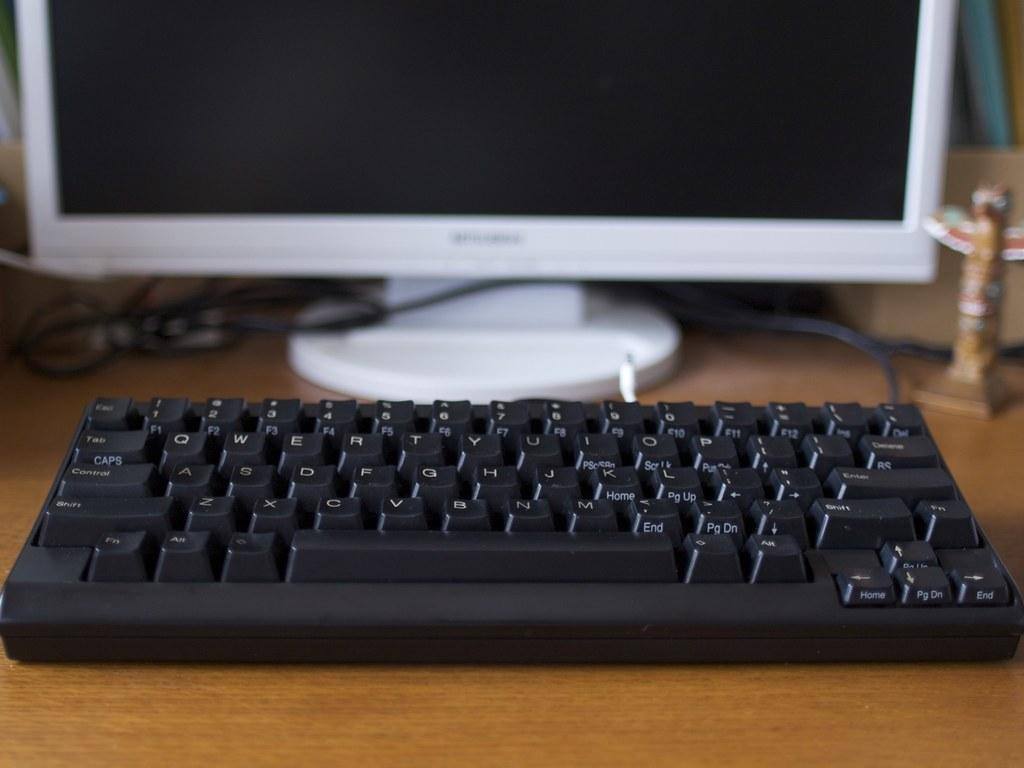What type of device is visible in the image? There is a keyboard in the image. What is the keyboard connected to? There is a monitor in the image, which the keyboard is likely connected to. Can you see the wall behind the keyboard in the image? The provided facts do not mention a wall behind the keyboard, so it cannot be confirmed from the image. 